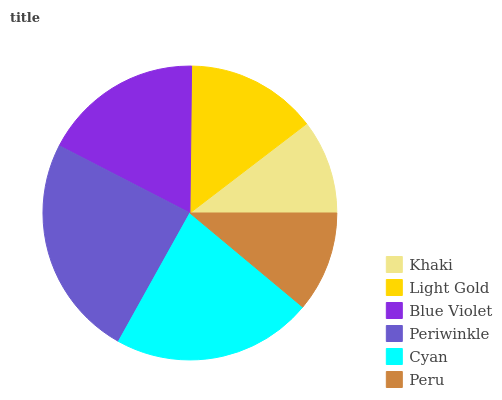Is Khaki the minimum?
Answer yes or no. Yes. Is Periwinkle the maximum?
Answer yes or no. Yes. Is Light Gold the minimum?
Answer yes or no. No. Is Light Gold the maximum?
Answer yes or no. No. Is Light Gold greater than Khaki?
Answer yes or no. Yes. Is Khaki less than Light Gold?
Answer yes or no. Yes. Is Khaki greater than Light Gold?
Answer yes or no. No. Is Light Gold less than Khaki?
Answer yes or no. No. Is Blue Violet the high median?
Answer yes or no. Yes. Is Light Gold the low median?
Answer yes or no. Yes. Is Cyan the high median?
Answer yes or no. No. Is Cyan the low median?
Answer yes or no. No. 